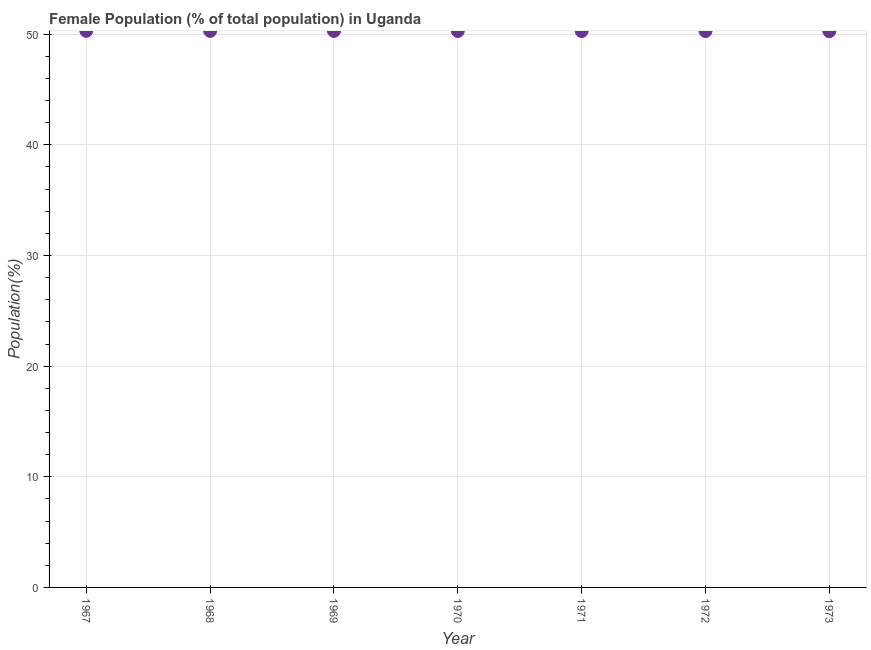What is the female population in 1972?
Offer a very short reply. 50.28. Across all years, what is the maximum female population?
Your answer should be compact. 50.31. Across all years, what is the minimum female population?
Provide a short and direct response. 50.28. In which year was the female population maximum?
Provide a short and direct response. 1967. In which year was the female population minimum?
Ensure brevity in your answer.  1973. What is the sum of the female population?
Offer a very short reply. 352.06. What is the difference between the female population in 1969 and 1970?
Your response must be concise. 0. What is the average female population per year?
Keep it short and to the point. 50.29. What is the median female population?
Your answer should be very brief. 50.29. Do a majority of the years between 1968 and 1969 (inclusive) have female population greater than 30 %?
Provide a short and direct response. Yes. What is the ratio of the female population in 1970 to that in 1971?
Your response must be concise. 1. What is the difference between the highest and the second highest female population?
Keep it short and to the point. 0. What is the difference between the highest and the lowest female population?
Make the answer very short. 0.03. Does the female population monotonically increase over the years?
Your answer should be compact. No. How many dotlines are there?
Your answer should be very brief. 1. Does the graph contain any zero values?
Offer a terse response. No. Does the graph contain grids?
Ensure brevity in your answer.  Yes. What is the title of the graph?
Provide a short and direct response. Female Population (% of total population) in Uganda. What is the label or title of the Y-axis?
Your answer should be compact. Population(%). What is the Population(%) in 1967?
Offer a very short reply. 50.31. What is the Population(%) in 1968?
Keep it short and to the point. 50.3. What is the Population(%) in 1969?
Offer a terse response. 50.3. What is the Population(%) in 1970?
Provide a succinct answer. 50.29. What is the Population(%) in 1971?
Offer a terse response. 50.29. What is the Population(%) in 1972?
Your answer should be compact. 50.28. What is the Population(%) in 1973?
Offer a terse response. 50.28. What is the difference between the Population(%) in 1967 and 1968?
Your answer should be very brief. 0. What is the difference between the Population(%) in 1967 and 1969?
Make the answer very short. 0.01. What is the difference between the Population(%) in 1967 and 1970?
Offer a terse response. 0.01. What is the difference between the Population(%) in 1967 and 1971?
Offer a terse response. 0.02. What is the difference between the Population(%) in 1967 and 1972?
Provide a succinct answer. 0.02. What is the difference between the Population(%) in 1967 and 1973?
Offer a very short reply. 0.03. What is the difference between the Population(%) in 1968 and 1969?
Offer a terse response. 0. What is the difference between the Population(%) in 1968 and 1970?
Give a very brief answer. 0.01. What is the difference between the Population(%) in 1968 and 1971?
Your answer should be very brief. 0.01. What is the difference between the Population(%) in 1968 and 1972?
Make the answer very short. 0.02. What is the difference between the Population(%) in 1968 and 1973?
Your answer should be very brief. 0.02. What is the difference between the Population(%) in 1969 and 1970?
Give a very brief answer. 0. What is the difference between the Population(%) in 1969 and 1971?
Keep it short and to the point. 0.01. What is the difference between the Population(%) in 1969 and 1972?
Ensure brevity in your answer.  0.01. What is the difference between the Population(%) in 1969 and 1973?
Your response must be concise. 0.02. What is the difference between the Population(%) in 1970 and 1971?
Provide a short and direct response. 0. What is the difference between the Population(%) in 1970 and 1972?
Your response must be concise. 0.01. What is the difference between the Population(%) in 1970 and 1973?
Your response must be concise. 0.01. What is the difference between the Population(%) in 1971 and 1972?
Make the answer very short. 0. What is the difference between the Population(%) in 1971 and 1973?
Provide a short and direct response. 0.01. What is the difference between the Population(%) in 1972 and 1973?
Offer a very short reply. 0. What is the ratio of the Population(%) in 1967 to that in 1968?
Your answer should be very brief. 1. What is the ratio of the Population(%) in 1967 to that in 1969?
Give a very brief answer. 1. What is the ratio of the Population(%) in 1967 to that in 1970?
Your answer should be compact. 1. What is the ratio of the Population(%) in 1967 to that in 1973?
Offer a very short reply. 1. What is the ratio of the Population(%) in 1968 to that in 1969?
Provide a succinct answer. 1. What is the ratio of the Population(%) in 1968 to that in 1972?
Offer a very short reply. 1. What is the ratio of the Population(%) in 1969 to that in 1970?
Provide a short and direct response. 1. What is the ratio of the Population(%) in 1969 to that in 1973?
Provide a succinct answer. 1. 